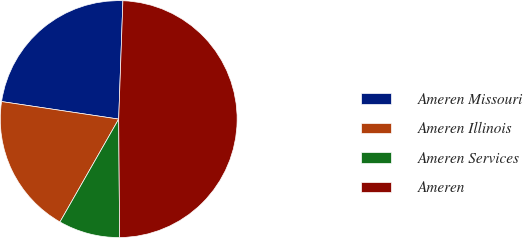Convert chart to OTSL. <chart><loc_0><loc_0><loc_500><loc_500><pie_chart><fcel>Ameren Missouri<fcel>Ameren Illinois<fcel>Ameren Services<fcel>Ameren<nl><fcel>23.2%<fcel>19.11%<fcel>8.38%<fcel>49.31%<nl></chart> 